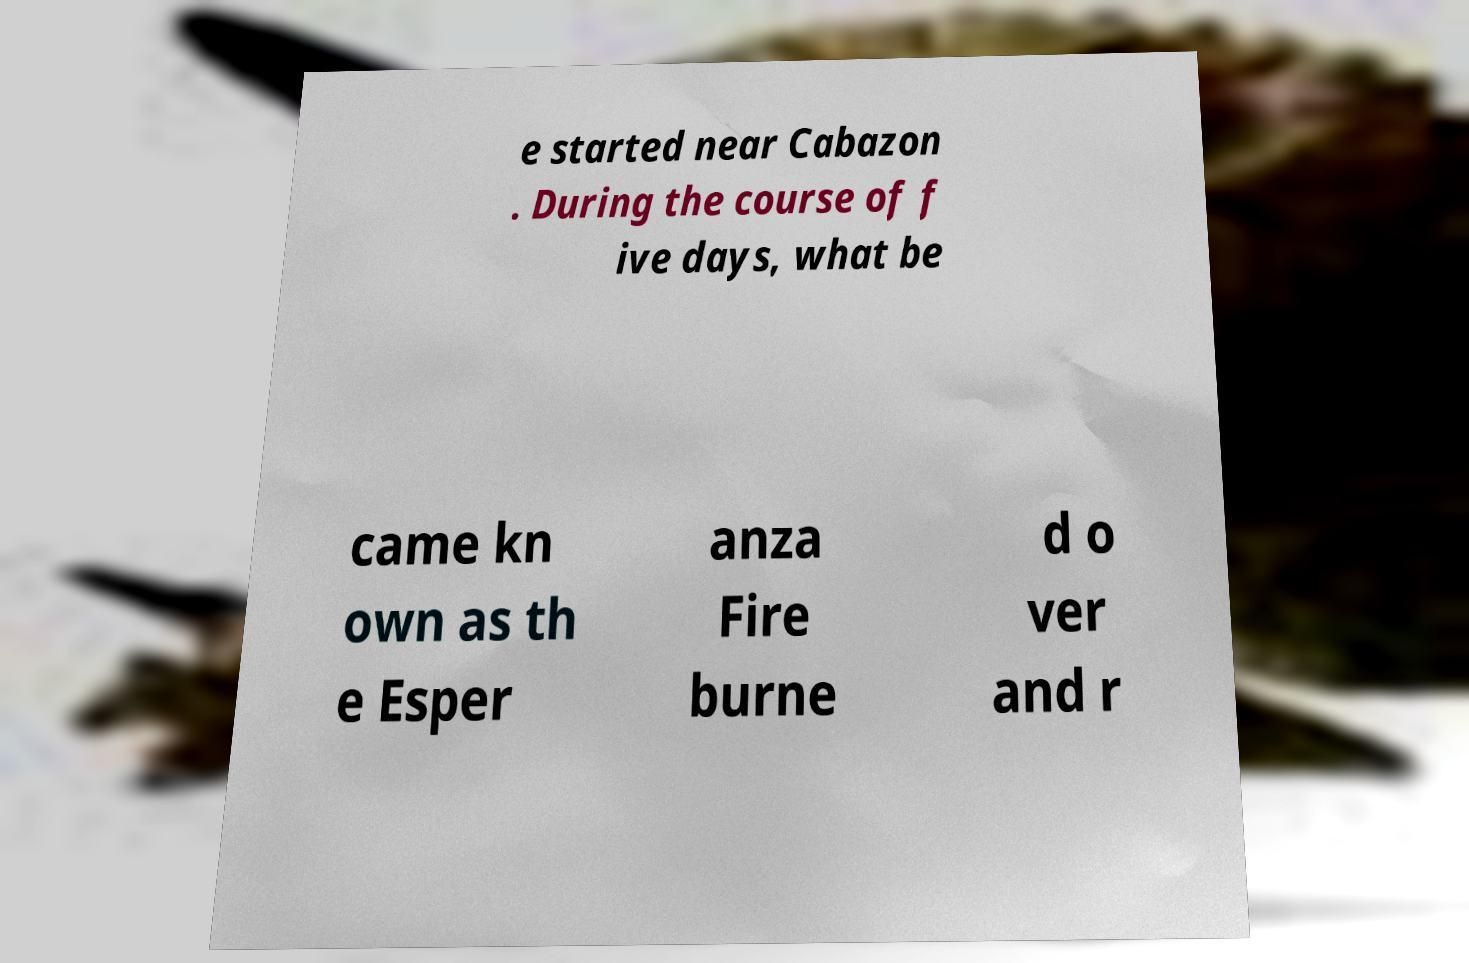Can you accurately transcribe the text from the provided image for me? e started near Cabazon . During the course of f ive days, what be came kn own as th e Esper anza Fire burne d o ver and r 